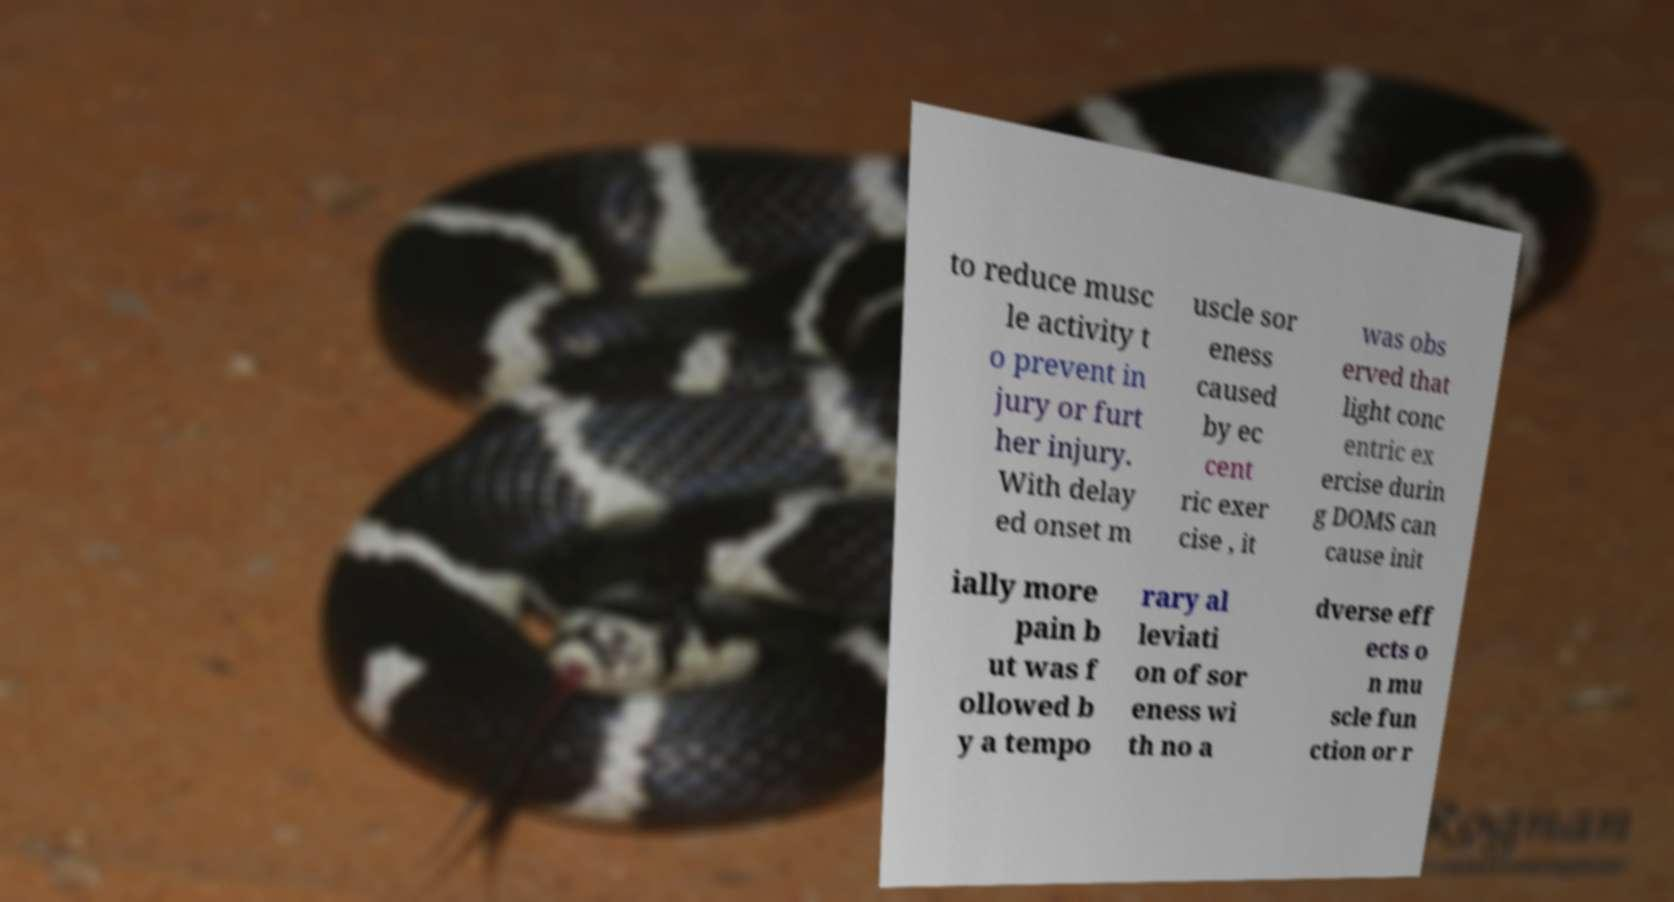What messages or text are displayed in this image? I need them in a readable, typed format. to reduce musc le activity t o prevent in jury or furt her injury. With delay ed onset m uscle sor eness caused by ec cent ric exer cise , it was obs erved that light conc entric ex ercise durin g DOMS can cause init ially more pain b ut was f ollowed b y a tempo rary al leviati on of sor eness wi th no a dverse eff ects o n mu scle fun ction or r 